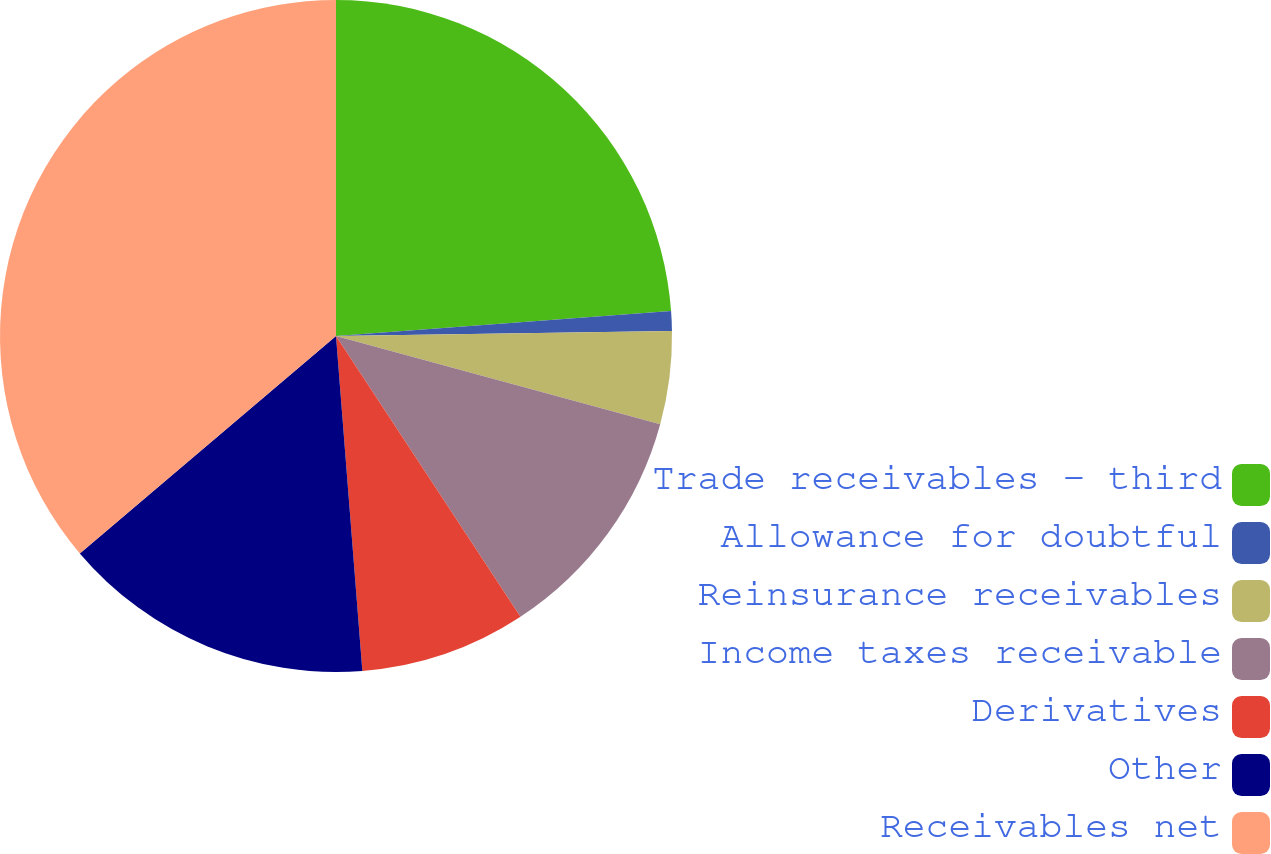Convert chart. <chart><loc_0><loc_0><loc_500><loc_500><pie_chart><fcel>Trade receivables - third<fcel>Allowance for doubtful<fcel>Reinsurance receivables<fcel>Income taxes receivable<fcel>Derivatives<fcel>Other<fcel>Receivables net<nl><fcel>23.82%<fcel>0.94%<fcel>4.47%<fcel>11.52%<fcel>8.0%<fcel>15.05%<fcel>36.2%<nl></chart> 